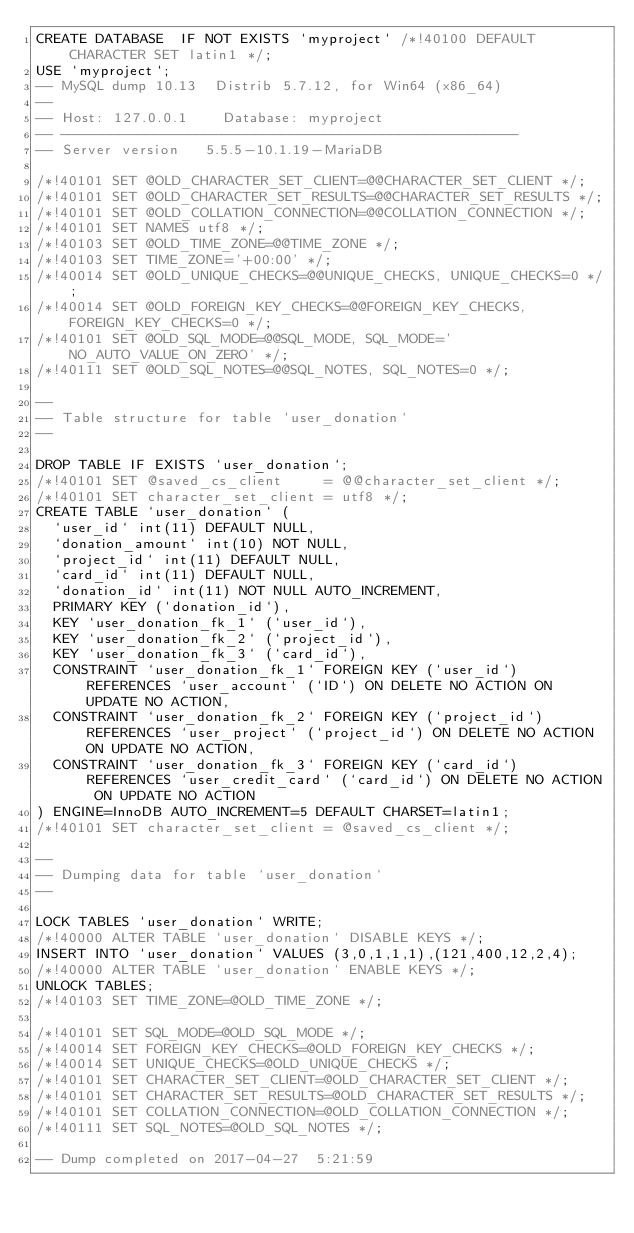<code> <loc_0><loc_0><loc_500><loc_500><_SQL_>CREATE DATABASE  IF NOT EXISTS `myproject` /*!40100 DEFAULT CHARACTER SET latin1 */;
USE `myproject`;
-- MySQL dump 10.13  Distrib 5.7.12, for Win64 (x86_64)
--
-- Host: 127.0.0.1    Database: myproject
-- ------------------------------------------------------
-- Server version	5.5.5-10.1.19-MariaDB

/*!40101 SET @OLD_CHARACTER_SET_CLIENT=@@CHARACTER_SET_CLIENT */;
/*!40101 SET @OLD_CHARACTER_SET_RESULTS=@@CHARACTER_SET_RESULTS */;
/*!40101 SET @OLD_COLLATION_CONNECTION=@@COLLATION_CONNECTION */;
/*!40101 SET NAMES utf8 */;
/*!40103 SET @OLD_TIME_ZONE=@@TIME_ZONE */;
/*!40103 SET TIME_ZONE='+00:00' */;
/*!40014 SET @OLD_UNIQUE_CHECKS=@@UNIQUE_CHECKS, UNIQUE_CHECKS=0 */;
/*!40014 SET @OLD_FOREIGN_KEY_CHECKS=@@FOREIGN_KEY_CHECKS, FOREIGN_KEY_CHECKS=0 */;
/*!40101 SET @OLD_SQL_MODE=@@SQL_MODE, SQL_MODE='NO_AUTO_VALUE_ON_ZERO' */;
/*!40111 SET @OLD_SQL_NOTES=@@SQL_NOTES, SQL_NOTES=0 */;

--
-- Table structure for table `user_donation`
--

DROP TABLE IF EXISTS `user_donation`;
/*!40101 SET @saved_cs_client     = @@character_set_client */;
/*!40101 SET character_set_client = utf8 */;
CREATE TABLE `user_donation` (
  `user_id` int(11) DEFAULT NULL,
  `donation_amount` int(10) NOT NULL,
  `project_id` int(11) DEFAULT NULL,
  `card_id` int(11) DEFAULT NULL,
  `donation_id` int(11) NOT NULL AUTO_INCREMENT,
  PRIMARY KEY (`donation_id`),
  KEY `user_donation_fk_1` (`user_id`),
  KEY `user_donation_fk_2` (`project_id`),
  KEY `user_donation_fk_3` (`card_id`),
  CONSTRAINT `user_donation_fk_1` FOREIGN KEY (`user_id`) REFERENCES `user_account` (`ID`) ON DELETE NO ACTION ON UPDATE NO ACTION,
  CONSTRAINT `user_donation_fk_2` FOREIGN KEY (`project_id`) REFERENCES `user_project` (`project_id`) ON DELETE NO ACTION ON UPDATE NO ACTION,
  CONSTRAINT `user_donation_fk_3` FOREIGN KEY (`card_id`) REFERENCES `user_credit_card` (`card_id`) ON DELETE NO ACTION ON UPDATE NO ACTION
) ENGINE=InnoDB AUTO_INCREMENT=5 DEFAULT CHARSET=latin1;
/*!40101 SET character_set_client = @saved_cs_client */;

--
-- Dumping data for table `user_donation`
--

LOCK TABLES `user_donation` WRITE;
/*!40000 ALTER TABLE `user_donation` DISABLE KEYS */;
INSERT INTO `user_donation` VALUES (3,0,1,1,1),(121,400,12,2,4);
/*!40000 ALTER TABLE `user_donation` ENABLE KEYS */;
UNLOCK TABLES;
/*!40103 SET TIME_ZONE=@OLD_TIME_ZONE */;

/*!40101 SET SQL_MODE=@OLD_SQL_MODE */;
/*!40014 SET FOREIGN_KEY_CHECKS=@OLD_FOREIGN_KEY_CHECKS */;
/*!40014 SET UNIQUE_CHECKS=@OLD_UNIQUE_CHECKS */;
/*!40101 SET CHARACTER_SET_CLIENT=@OLD_CHARACTER_SET_CLIENT */;
/*!40101 SET CHARACTER_SET_RESULTS=@OLD_CHARACTER_SET_RESULTS */;
/*!40101 SET COLLATION_CONNECTION=@OLD_COLLATION_CONNECTION */;
/*!40111 SET SQL_NOTES=@OLD_SQL_NOTES */;

-- Dump completed on 2017-04-27  5:21:59
</code> 